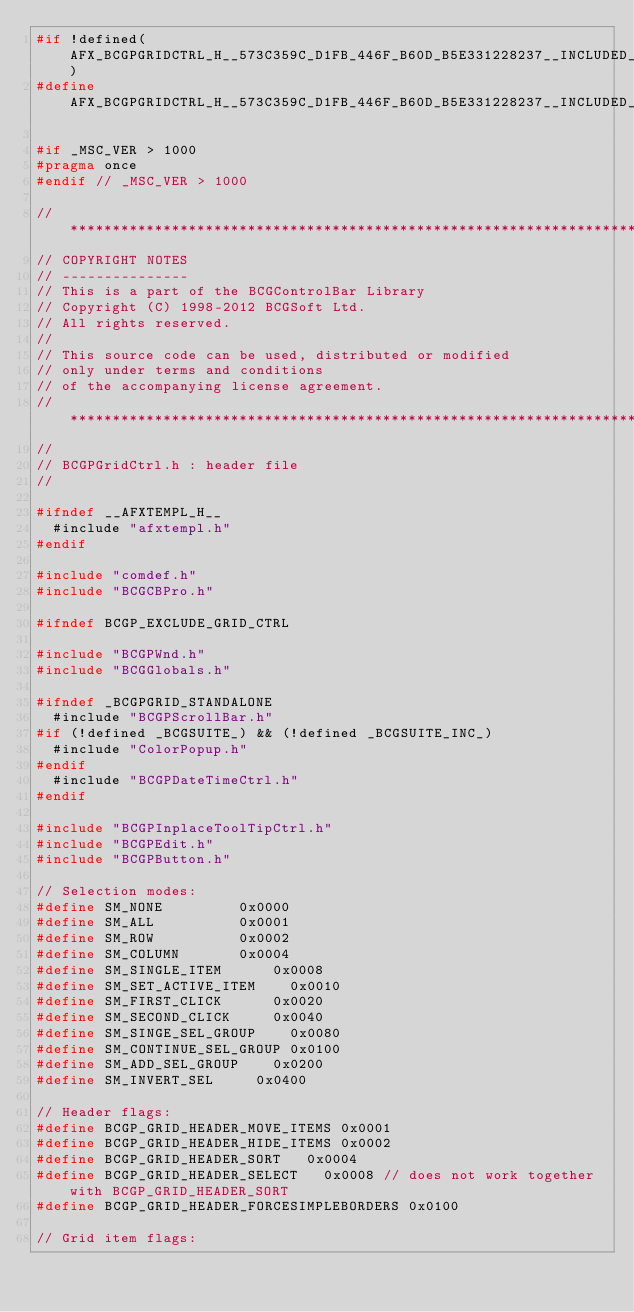Convert code to text. <code><loc_0><loc_0><loc_500><loc_500><_C_>#if !defined(AFX_BCGPGRIDCTRL_H__573C359C_D1FB_446F_B60D_B5E331228237__INCLUDED_)
#define AFX_BCGPGRIDCTRL_H__573C359C_D1FB_446F_B60D_B5E331228237__INCLUDED_

#if _MSC_VER > 1000
#pragma once
#endif // _MSC_VER > 1000

//*******************************************************************************
// COPYRIGHT NOTES
// ---------------
// This is a part of the BCGControlBar Library
// Copyright (C) 1998-2012 BCGSoft Ltd.
// All rights reserved.
//
// This source code can be used, distributed or modified
// only under terms and conditions 
// of the accompanying license agreement.
//*******************************************************************************
//
// BCGPGridCtrl.h : header file
//

#ifndef __AFXTEMPL_H__
	#include "afxtempl.h"
#endif

#include "comdef.h"
#include "BCGCBPro.h"

#ifndef BCGP_EXCLUDE_GRID_CTRL

#include "BCGPWnd.h"
#include "BCGGlobals.h"

#ifndef _BCGPGRID_STANDALONE
	#include "BCGPScrollBar.h"
#if (!defined _BCGSUITE_) && (!defined _BCGSUITE_INC_)
	#include "ColorPopup.h"
#endif
	#include "BCGPDateTimeCtrl.h"
#endif

#include "BCGPInplaceToolTipCtrl.h"
#include "BCGPEdit.h"
#include "BCGPButton.h"

// Selection modes:
#define SM_NONE					0x0000
#define SM_ALL					0x0001
#define SM_ROW					0x0002
#define SM_COLUMN				0x0004
#define SM_SINGLE_ITEM			0x0008
#define SM_SET_ACTIVE_ITEM		0x0010
#define SM_FIRST_CLICK			0x0020
#define SM_SECOND_CLICK			0x0040
#define SM_SINGE_SEL_GROUP		0x0080
#define SM_CONTINUE_SEL_GROUP	0x0100
#define SM_ADD_SEL_GROUP		0x0200
#define SM_INVERT_SEL			0x0400

// Header flags:
#define BCGP_GRID_HEADER_MOVE_ITEMS	0x0001
#define BCGP_GRID_HEADER_HIDE_ITEMS	0x0002
#define BCGP_GRID_HEADER_SORT		0x0004
#define BCGP_GRID_HEADER_SELECT		0x0008 // does not work together with BCGP_GRID_HEADER_SORT
#define BCGP_GRID_HEADER_FORCESIMPLEBORDERS 0x0100

// Grid item flags:</code> 